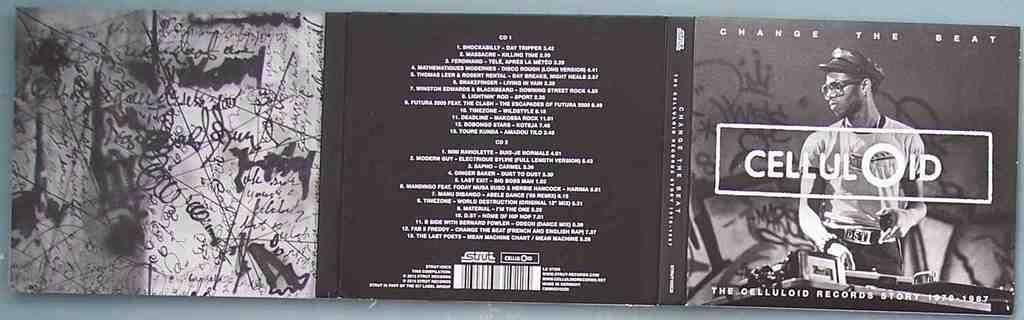<image>
Describe the image concisely. A cd by Celluloid titled Change the Beat, The Celluloid Record Story. 